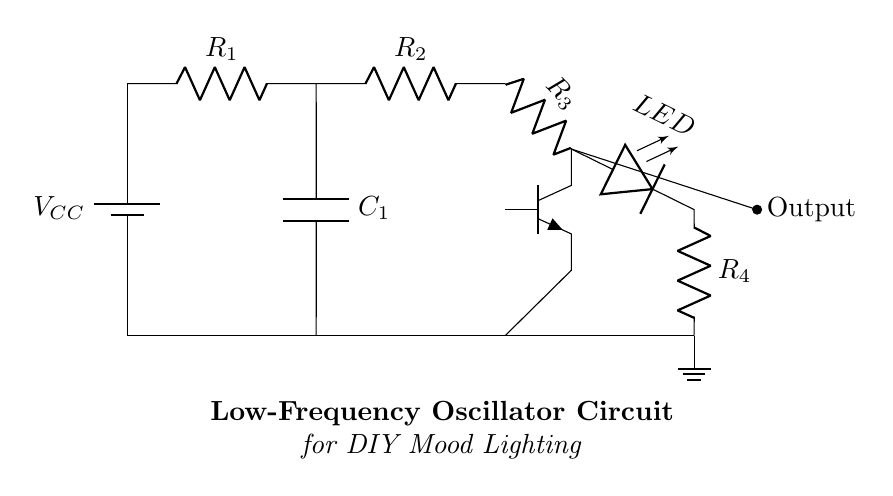What type of transistor is used in this circuit? The circuit uses an npn transistor, as indicated by the symbol shown in the diagram.
Answer: npn What component is responsible for the output light in the circuit? The component responsible for the output light is the LED, which is directly connected to the collector of the transistor and is used to emit light when current passes through it.
Answer: LED What is the role of the capacitor in this circuit? The capacitor acts to smooth out the voltage fluctuations and integrates the charge over time, which helps in generating a low-frequency oscillation.
Answer: Smooth voltage What determines the oscillation frequency in this circuit? The oscillation frequency is determined by the resistor and capacitor values in the RC network, specifically the combination of R1, R2, and C1, as they define the time constant used for charging and discharging.
Answer: R1, R2, and C1 What is the function of the battery in the circuit? The battery provides the necessary supply voltage, V_CC, to power the entire circuit and maintain its operation.
Answer: Supply voltage How does the transistor function in this circuit? The transistor acts as a switch or amplifier, controlling the current flow to the LED based on the input from the RC network, which enables the oscillation effect for the mood lighting.
Answer: Switch/amplifier What is the purpose of the resistors in the circuit? The resistors limit the current flowing through the circuit, protecting components like the LED and controlling the timing of the oscillation created by the RC network.
Answer: Limit current 